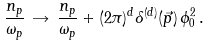Convert formula to latex. <formula><loc_0><loc_0><loc_500><loc_500>\frac { n _ { p } } { \omega _ { p } } \, \rightarrow \, \frac { n _ { p } } { \omega _ { p } } + ( 2 \pi ) ^ { d } \delta ^ { ( d ) } ( \vec { p } ) \, \phi _ { 0 } ^ { 2 } \, .</formula> 